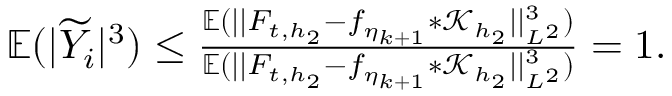<formula> <loc_0><loc_0><loc_500><loc_500>\begin{array} { r } { \mathbb { E } ( | \widetilde { Y } _ { i } | ^ { 3 } ) \leq \frac { \mathbb { E } ( | | F _ { t , { h _ { 2 } } } - f _ { \eta _ { k + 1 } } \ast \mathcal { K } _ { h _ { 2 } } | | _ { L ^ { 2 } } ^ { 3 } ) } { \mathbb { E } ( | | F _ { t , { h _ { 2 } } } - f _ { \eta _ { k + 1 } } \ast \mathcal { K } _ { h _ { 2 } } | | _ { L ^ { 2 } } ^ { 3 } ) } = 1 . } \end{array}</formula> 